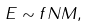<formula> <loc_0><loc_0><loc_500><loc_500>E \sim f N M ,</formula> 